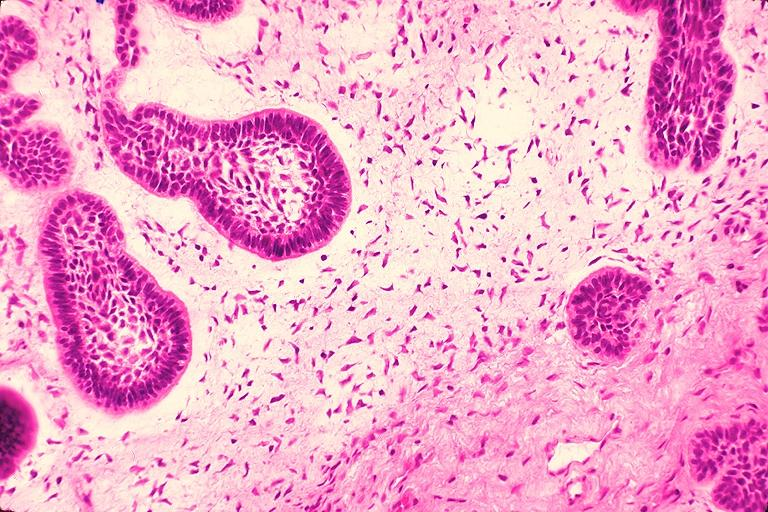what is present?
Answer the question using a single word or phrase. Oral 